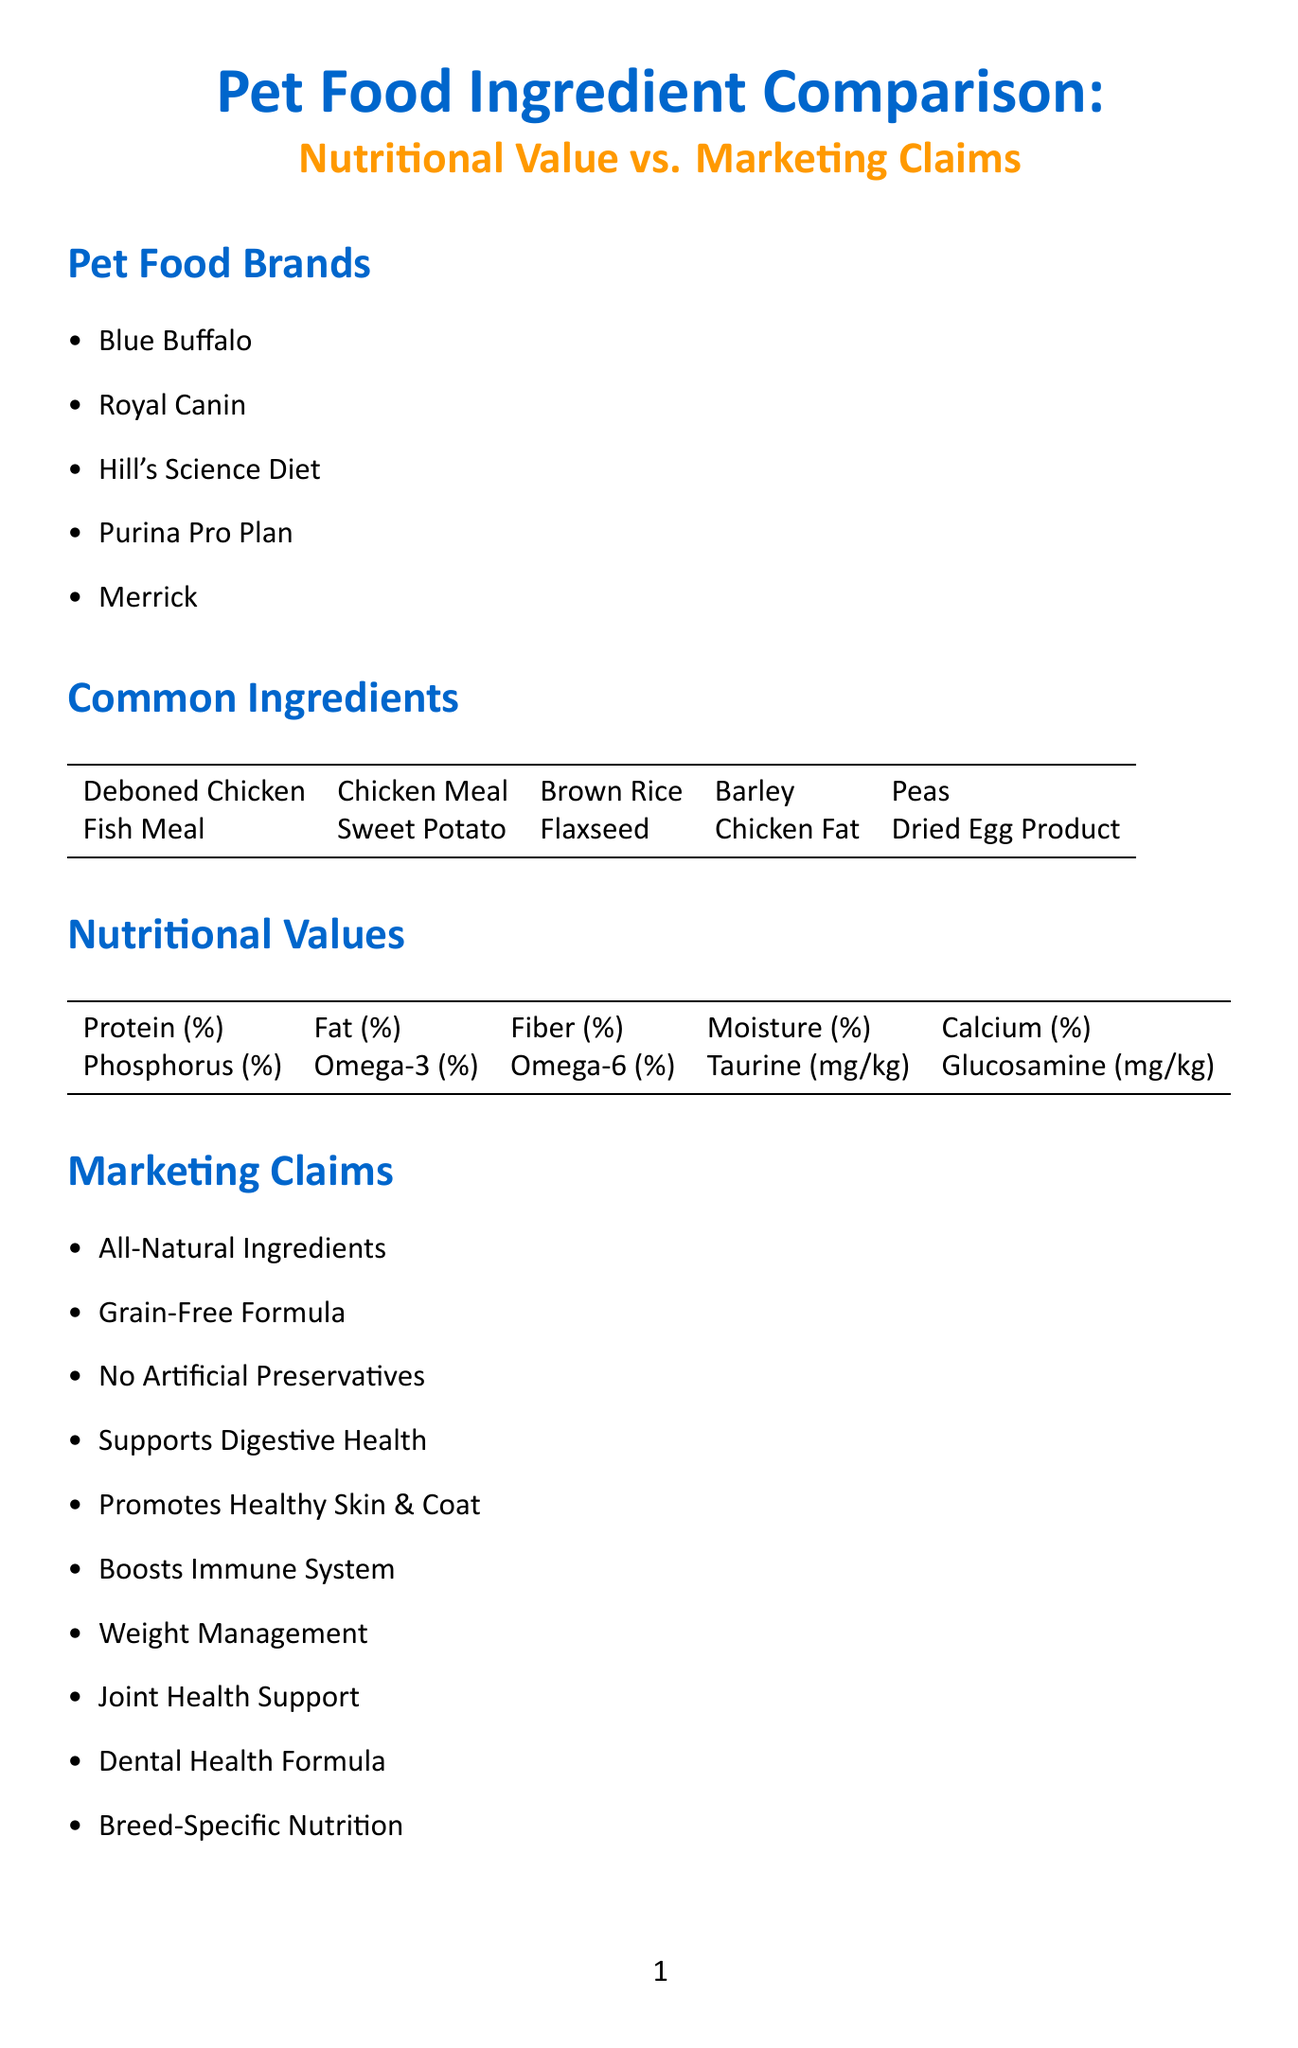What is the chart title? The chart title is stated at the beginning of the document and provides an overview of the content that follows.
Answer: Pet Food Ingredient Comparison: Nutritional Value vs. Marketing Claims Name three pet food brands listed. The document provides a list of five pet food brands in the "Pet Food Brands" section. Choosing any three from this list answers the question.
Answer: Blue Buffalo, Royal Canin, Hill's Science Diet What percentage of protein is listed as a nutritional value? The nutritional values section includes various nutrients that are evaluated in the pet food, with protein being one of them.
Answer: Protein (%) Which marketing claim mentions joint support? The marketing claims include specific phrases designed to convey advantages of the pet food, and one of them directly refers to joint health.
Answer: Joint Health Support How many criteria are listed for claim analysis? The document enumerates the criteria for analyzing marketing claims in a specific section, making it easy to count them.
Answer: Five What guideline is referenced for dog food nutrient profiles? The nutritional guidelines section specifically mentions authoritative guidelines for pet nutrition, including those for dog food.
Answer: AAFCO Dog Food Nutrient Profiles Which ingredient is classified as a healthy fat in this document? The common ingredients listed include sources of fats, and one that is commonly associated with healthy fats is noted in the document.
Answer: Chicken Fat What is the first point in expert commentary? The expert commentary section begins with a specific point emphasizing balanced nutrition, as listed in the document's content.
Answer: Importance of Balanced Nutrition How many additional considerations are mentioned? The document specifies a section about additional considerations, making it straightforward to count the items listed.
Answer: Seven 